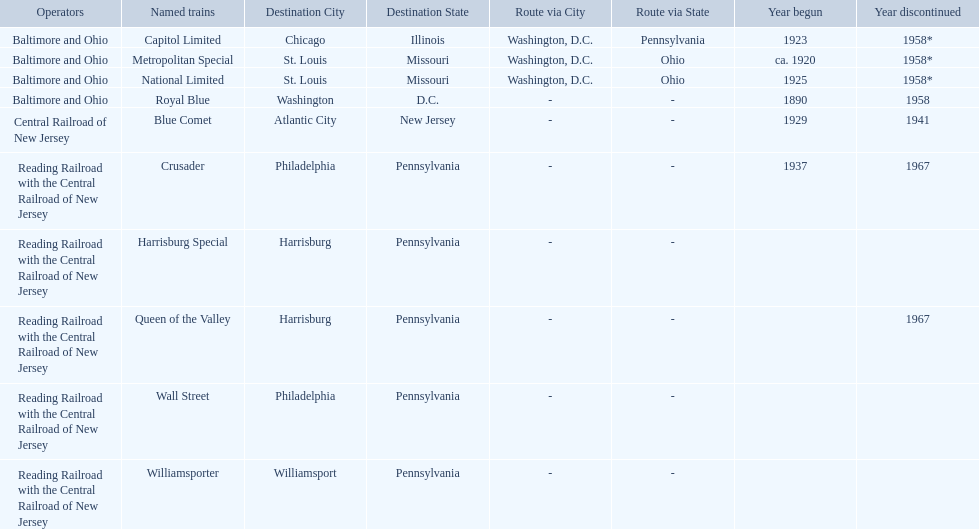What is the difference (in years) between when the royal blue began and the year the crusader began? 47. 